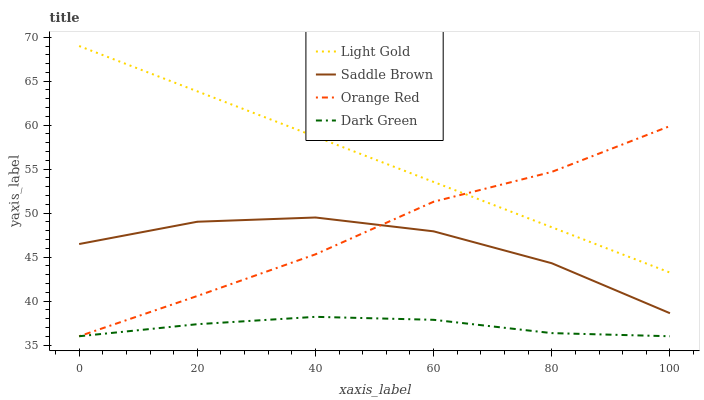Does Dark Green have the minimum area under the curve?
Answer yes or no. Yes. Does Light Gold have the maximum area under the curve?
Answer yes or no. Yes. Does Saddle Brown have the minimum area under the curve?
Answer yes or no. No. Does Saddle Brown have the maximum area under the curve?
Answer yes or no. No. Is Light Gold the smoothest?
Answer yes or no. Yes. Is Saddle Brown the roughest?
Answer yes or no. Yes. Is Saddle Brown the smoothest?
Answer yes or no. No. Is Light Gold the roughest?
Answer yes or no. No. Does Dark Green have the lowest value?
Answer yes or no. Yes. Does Saddle Brown have the lowest value?
Answer yes or no. No. Does Light Gold have the highest value?
Answer yes or no. Yes. Does Saddle Brown have the highest value?
Answer yes or no. No. Is Dark Green less than Light Gold?
Answer yes or no. Yes. Is Saddle Brown greater than Dark Green?
Answer yes or no. Yes. Does Dark Green intersect Orange Red?
Answer yes or no. Yes. Is Dark Green less than Orange Red?
Answer yes or no. No. Is Dark Green greater than Orange Red?
Answer yes or no. No. Does Dark Green intersect Light Gold?
Answer yes or no. No. 